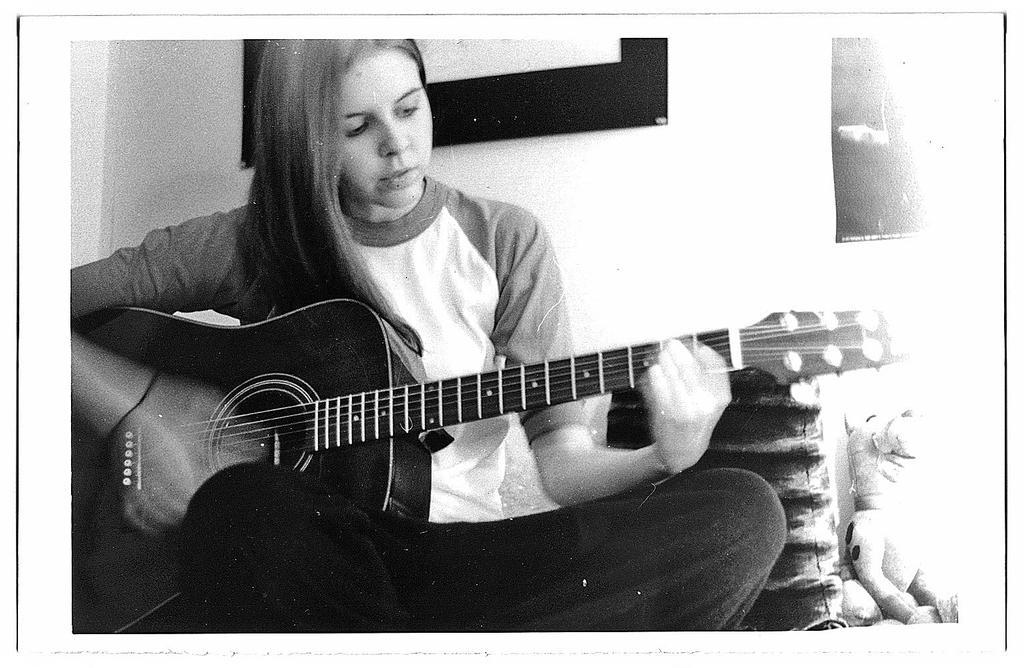How would you summarize this image in a sentence or two? The girl wearing black pant is playing guitar and there is a toy beside her. 